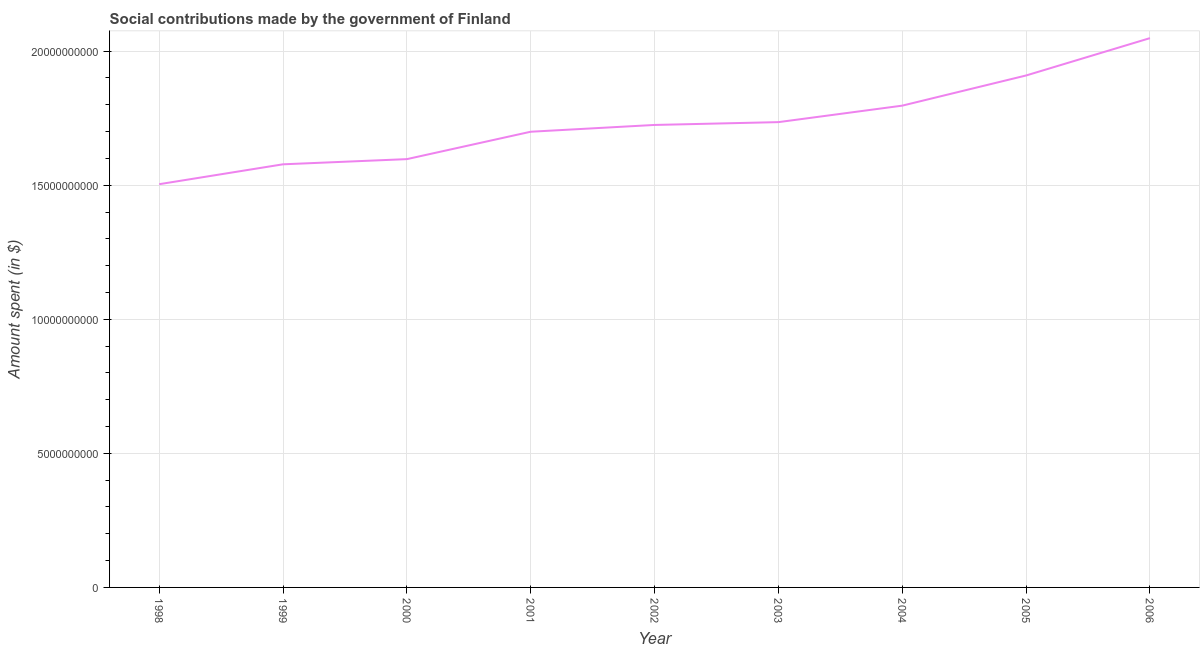What is the amount spent in making social contributions in 2006?
Offer a terse response. 2.05e+1. Across all years, what is the maximum amount spent in making social contributions?
Keep it short and to the point. 2.05e+1. Across all years, what is the minimum amount spent in making social contributions?
Keep it short and to the point. 1.50e+1. In which year was the amount spent in making social contributions maximum?
Make the answer very short. 2006. In which year was the amount spent in making social contributions minimum?
Your answer should be very brief. 1998. What is the sum of the amount spent in making social contributions?
Make the answer very short. 1.56e+11. What is the difference between the amount spent in making social contributions in 1998 and 2000?
Your response must be concise. -9.35e+08. What is the average amount spent in making social contributions per year?
Make the answer very short. 1.73e+1. What is the median amount spent in making social contributions?
Offer a terse response. 1.72e+1. Do a majority of the years between 2003 and 2005 (inclusive) have amount spent in making social contributions greater than 5000000000 $?
Keep it short and to the point. Yes. What is the ratio of the amount spent in making social contributions in 1998 to that in 2006?
Your answer should be very brief. 0.73. Is the amount spent in making social contributions in 2001 less than that in 2005?
Keep it short and to the point. Yes. Is the difference between the amount spent in making social contributions in 2001 and 2004 greater than the difference between any two years?
Ensure brevity in your answer.  No. What is the difference between the highest and the second highest amount spent in making social contributions?
Your answer should be compact. 1.39e+09. Is the sum of the amount spent in making social contributions in 1999 and 2006 greater than the maximum amount spent in making social contributions across all years?
Ensure brevity in your answer.  Yes. What is the difference between the highest and the lowest amount spent in making social contributions?
Make the answer very short. 5.45e+09. How many lines are there?
Make the answer very short. 1. How many years are there in the graph?
Offer a terse response. 9. What is the title of the graph?
Your response must be concise. Social contributions made by the government of Finland. What is the label or title of the Y-axis?
Make the answer very short. Amount spent (in $). What is the Amount spent (in $) in 1998?
Offer a very short reply. 1.50e+1. What is the Amount spent (in $) of 1999?
Make the answer very short. 1.58e+1. What is the Amount spent (in $) in 2000?
Ensure brevity in your answer.  1.60e+1. What is the Amount spent (in $) in 2001?
Offer a very short reply. 1.70e+1. What is the Amount spent (in $) of 2002?
Make the answer very short. 1.72e+1. What is the Amount spent (in $) in 2003?
Give a very brief answer. 1.74e+1. What is the Amount spent (in $) in 2004?
Your answer should be very brief. 1.80e+1. What is the Amount spent (in $) in 2005?
Your answer should be very brief. 1.91e+1. What is the Amount spent (in $) in 2006?
Your answer should be very brief. 2.05e+1. What is the difference between the Amount spent (in $) in 1998 and 1999?
Your response must be concise. -7.42e+08. What is the difference between the Amount spent (in $) in 1998 and 2000?
Your answer should be compact. -9.35e+08. What is the difference between the Amount spent (in $) in 1998 and 2001?
Provide a succinct answer. -1.96e+09. What is the difference between the Amount spent (in $) in 1998 and 2002?
Provide a short and direct response. -2.21e+09. What is the difference between the Amount spent (in $) in 1998 and 2003?
Make the answer very short. -2.32e+09. What is the difference between the Amount spent (in $) in 1998 and 2004?
Offer a very short reply. -2.93e+09. What is the difference between the Amount spent (in $) in 1998 and 2005?
Ensure brevity in your answer.  -4.06e+09. What is the difference between the Amount spent (in $) in 1998 and 2006?
Provide a short and direct response. -5.45e+09. What is the difference between the Amount spent (in $) in 1999 and 2000?
Your response must be concise. -1.93e+08. What is the difference between the Amount spent (in $) in 1999 and 2001?
Offer a very short reply. -1.22e+09. What is the difference between the Amount spent (in $) in 1999 and 2002?
Provide a short and direct response. -1.47e+09. What is the difference between the Amount spent (in $) in 1999 and 2003?
Offer a very short reply. -1.57e+09. What is the difference between the Amount spent (in $) in 1999 and 2004?
Offer a terse response. -2.19e+09. What is the difference between the Amount spent (in $) in 1999 and 2005?
Offer a terse response. -3.31e+09. What is the difference between the Amount spent (in $) in 1999 and 2006?
Your answer should be compact. -4.71e+09. What is the difference between the Amount spent (in $) in 2000 and 2001?
Keep it short and to the point. -1.02e+09. What is the difference between the Amount spent (in $) in 2000 and 2002?
Make the answer very short. -1.28e+09. What is the difference between the Amount spent (in $) in 2000 and 2003?
Offer a terse response. -1.38e+09. What is the difference between the Amount spent (in $) in 2000 and 2004?
Your answer should be compact. -2.00e+09. What is the difference between the Amount spent (in $) in 2000 and 2005?
Your response must be concise. -3.12e+09. What is the difference between the Amount spent (in $) in 2000 and 2006?
Provide a succinct answer. -4.51e+09. What is the difference between the Amount spent (in $) in 2001 and 2002?
Make the answer very short. -2.53e+08. What is the difference between the Amount spent (in $) in 2001 and 2003?
Provide a succinct answer. -3.58e+08. What is the difference between the Amount spent (in $) in 2001 and 2004?
Provide a succinct answer. -9.73e+08. What is the difference between the Amount spent (in $) in 2001 and 2005?
Your response must be concise. -2.10e+09. What is the difference between the Amount spent (in $) in 2001 and 2006?
Provide a succinct answer. -3.49e+09. What is the difference between the Amount spent (in $) in 2002 and 2003?
Offer a very short reply. -1.05e+08. What is the difference between the Amount spent (in $) in 2002 and 2004?
Offer a very short reply. -7.20e+08. What is the difference between the Amount spent (in $) in 2002 and 2005?
Give a very brief answer. -1.84e+09. What is the difference between the Amount spent (in $) in 2002 and 2006?
Ensure brevity in your answer.  -3.24e+09. What is the difference between the Amount spent (in $) in 2003 and 2004?
Keep it short and to the point. -6.15e+08. What is the difference between the Amount spent (in $) in 2003 and 2005?
Offer a terse response. -1.74e+09. What is the difference between the Amount spent (in $) in 2003 and 2006?
Ensure brevity in your answer.  -3.13e+09. What is the difference between the Amount spent (in $) in 2004 and 2005?
Provide a succinct answer. -1.12e+09. What is the difference between the Amount spent (in $) in 2004 and 2006?
Your answer should be very brief. -2.52e+09. What is the difference between the Amount spent (in $) in 2005 and 2006?
Make the answer very short. -1.39e+09. What is the ratio of the Amount spent (in $) in 1998 to that in 1999?
Keep it short and to the point. 0.95. What is the ratio of the Amount spent (in $) in 1998 to that in 2000?
Offer a very short reply. 0.94. What is the ratio of the Amount spent (in $) in 1998 to that in 2001?
Your answer should be compact. 0.89. What is the ratio of the Amount spent (in $) in 1998 to that in 2002?
Ensure brevity in your answer.  0.87. What is the ratio of the Amount spent (in $) in 1998 to that in 2003?
Ensure brevity in your answer.  0.87. What is the ratio of the Amount spent (in $) in 1998 to that in 2004?
Keep it short and to the point. 0.84. What is the ratio of the Amount spent (in $) in 1998 to that in 2005?
Your answer should be very brief. 0.79. What is the ratio of the Amount spent (in $) in 1998 to that in 2006?
Your answer should be very brief. 0.73. What is the ratio of the Amount spent (in $) in 1999 to that in 2000?
Keep it short and to the point. 0.99. What is the ratio of the Amount spent (in $) in 1999 to that in 2001?
Your response must be concise. 0.93. What is the ratio of the Amount spent (in $) in 1999 to that in 2002?
Offer a terse response. 0.92. What is the ratio of the Amount spent (in $) in 1999 to that in 2003?
Keep it short and to the point. 0.91. What is the ratio of the Amount spent (in $) in 1999 to that in 2004?
Keep it short and to the point. 0.88. What is the ratio of the Amount spent (in $) in 1999 to that in 2005?
Offer a terse response. 0.83. What is the ratio of the Amount spent (in $) in 1999 to that in 2006?
Provide a succinct answer. 0.77. What is the ratio of the Amount spent (in $) in 2000 to that in 2002?
Offer a very short reply. 0.93. What is the ratio of the Amount spent (in $) in 2000 to that in 2003?
Your response must be concise. 0.92. What is the ratio of the Amount spent (in $) in 2000 to that in 2004?
Offer a terse response. 0.89. What is the ratio of the Amount spent (in $) in 2000 to that in 2005?
Offer a terse response. 0.84. What is the ratio of the Amount spent (in $) in 2000 to that in 2006?
Your answer should be very brief. 0.78. What is the ratio of the Amount spent (in $) in 2001 to that in 2002?
Give a very brief answer. 0.98. What is the ratio of the Amount spent (in $) in 2001 to that in 2003?
Keep it short and to the point. 0.98. What is the ratio of the Amount spent (in $) in 2001 to that in 2004?
Provide a short and direct response. 0.95. What is the ratio of the Amount spent (in $) in 2001 to that in 2005?
Ensure brevity in your answer.  0.89. What is the ratio of the Amount spent (in $) in 2001 to that in 2006?
Your answer should be very brief. 0.83. What is the ratio of the Amount spent (in $) in 2002 to that in 2004?
Your answer should be very brief. 0.96. What is the ratio of the Amount spent (in $) in 2002 to that in 2005?
Offer a terse response. 0.9. What is the ratio of the Amount spent (in $) in 2002 to that in 2006?
Offer a very short reply. 0.84. What is the ratio of the Amount spent (in $) in 2003 to that in 2005?
Give a very brief answer. 0.91. What is the ratio of the Amount spent (in $) in 2003 to that in 2006?
Your answer should be very brief. 0.85. What is the ratio of the Amount spent (in $) in 2004 to that in 2005?
Offer a very short reply. 0.94. What is the ratio of the Amount spent (in $) in 2004 to that in 2006?
Keep it short and to the point. 0.88. What is the ratio of the Amount spent (in $) in 2005 to that in 2006?
Make the answer very short. 0.93. 